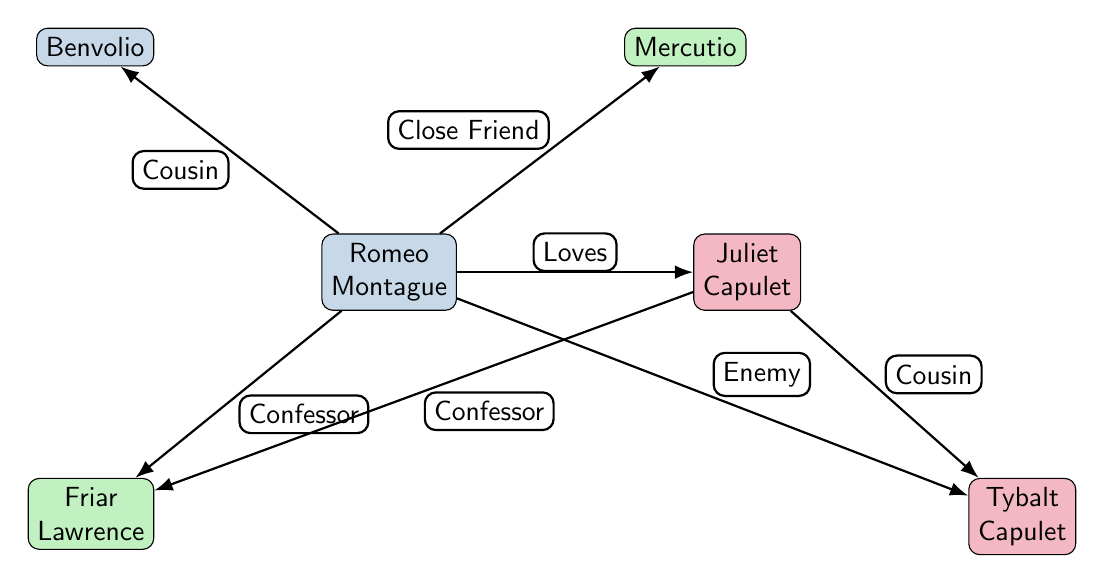What is the relationship between Romeo and Juliet? The diagram indicates a direct edge labeled "Loves" from Romeo to Juliet, which signifies that their relationship is based on love.
Answer: Loves How many characters are represented in the diagram? By counting the nodes, we can see there are a total of six characters: Romeo, Juliet, Mercutio, Tybalt, Friar Lawrence, and Benvolio.
Answer: 6 Who is Romeo's close friend? The diagram shows an edge from Romeo to Mercutio labeled "Close Friend," indicating that Mercutio is Romeo's close friend.
Answer: Mercutio What is the nature of Tybalt's relationship with Juliet? According to the diagram, there is an edge from Juliet to Tybalt labeled "Cousin," indicating that their relationship is that of cousins.
Answer: Cousin Which two characters have a conflict, as shown in the diagram? The diagram contains an edge from Romeo to Tybalt labeled "Enemy," illustrating that there is a conflict between these two characters.
Answer: Tybalt Who acts as a confessor for both Romeo and Juliet? The edges labeled "Confessor" point from both Romeo and Juliet to Friar Lawrence, indicating that he serves as a confessor for both characters.
Answer: Friar Lawrence How many edges are depicted in the diagram? By counting the edges depicted between the nodes, there are a total of six edges connecting the characters and their relationships.
Answer: 6 What role does Benvolio have in relation to Romeo? The diagram includes an edge labeled "Cousin" from Romeo to Benvolio, indicating that Benvolio is Romeo's cousin.
Answer: Cousin Which character is an enemy to Romeo? The edge from Romeo to Tybalt is labeled "Enemy," clearly indicating that Tybalt is Romeo's enemy.
Answer: Tybalt 